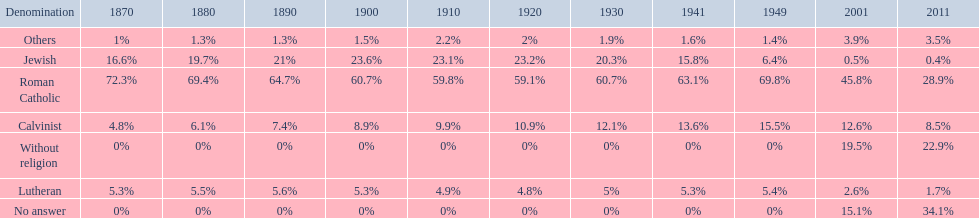Which denomination held the largest percentage in 1880? Roman Catholic. 